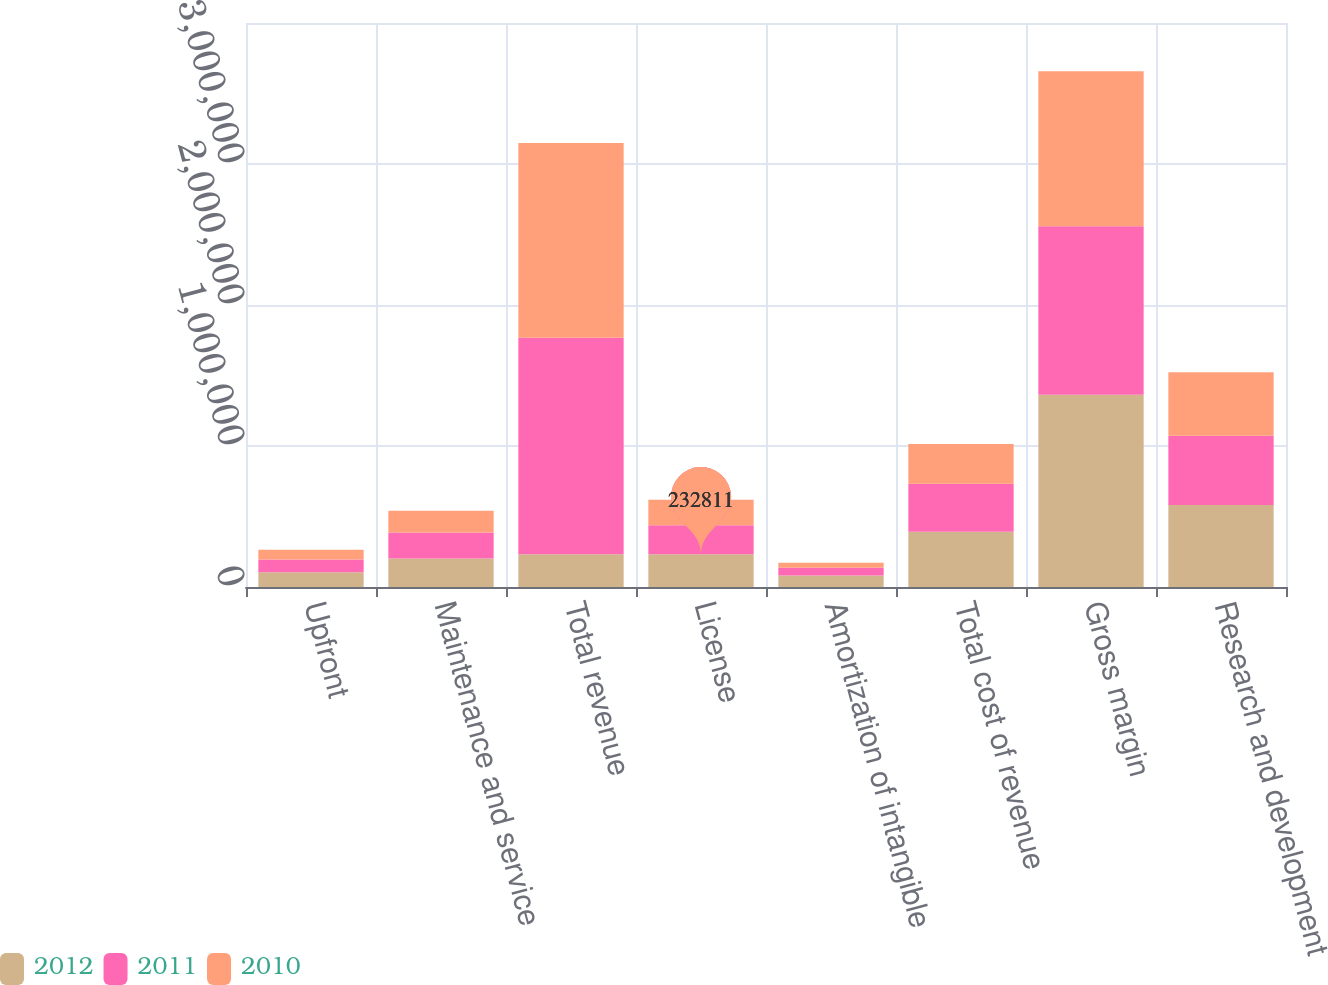Convert chart. <chart><loc_0><loc_0><loc_500><loc_500><stacked_bar_chart><ecel><fcel>Upfront<fcel>Maintenance and service<fcel>Total revenue<fcel>License<fcel>Amortization of intangible<fcel>Total cost of revenue<fcel>Gross margin<fcel>Research and development<nl><fcel>2012<fcel>105137<fcel>201580<fcel>232811<fcel>232811<fcel>81255<fcel>392673<fcel>1.36334e+06<fcel>581628<nl><fcel>2011<fcel>90531<fcel>184770<fcel>1.53564e+06<fcel>205390<fcel>54819<fcel>340450<fcel>1.19519e+06<fcel>491871<nl><fcel>2010<fcel>68618<fcel>153625<fcel>1.38066e+06<fcel>180245<fcel>36103<fcel>281094<fcel>1.09957e+06<fcel>449229<nl></chart> 